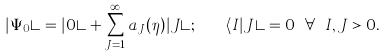Convert formula to latex. <formula><loc_0><loc_0><loc_500><loc_500>| \Psi _ { 0 } \rangle = | 0 \rangle + \sum _ { J = 1 } ^ { \infty } a _ { J } ( \eta ) | J \rangle ; \quad \langle I | J \rangle = 0 \ \forall \ I , J > 0 .</formula> 